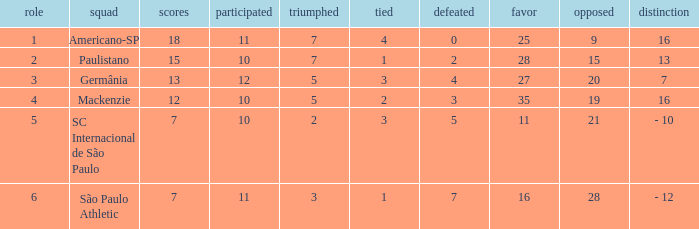Name the points for paulistano 15.0. 